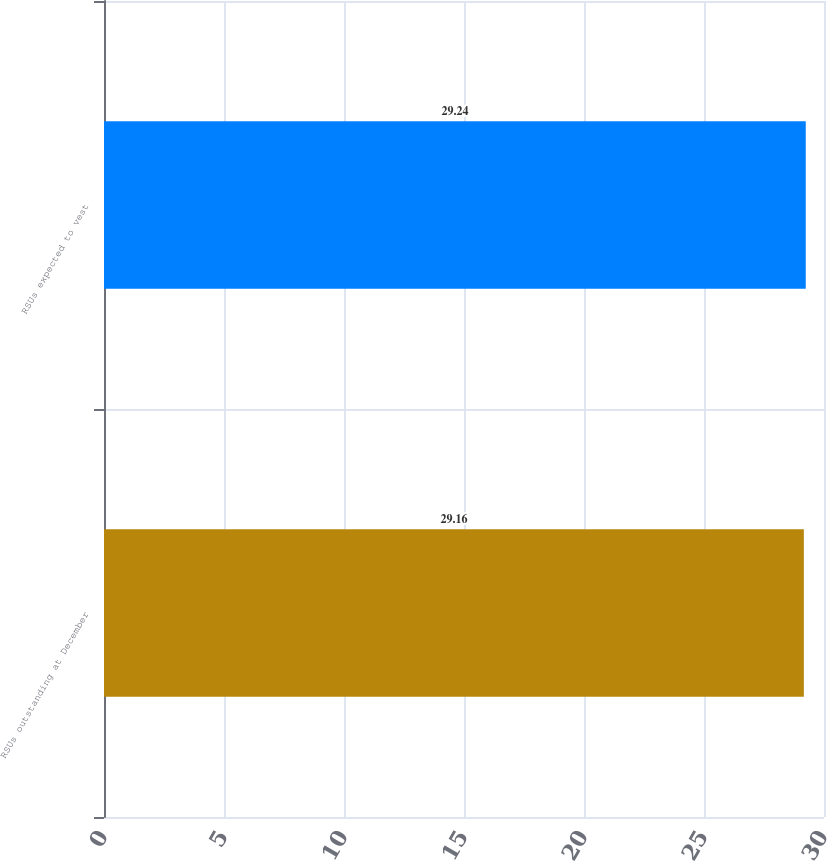Convert chart to OTSL. <chart><loc_0><loc_0><loc_500><loc_500><bar_chart><fcel>RSUs outstanding at December<fcel>RSUs expected to vest<nl><fcel>29.16<fcel>29.24<nl></chart> 